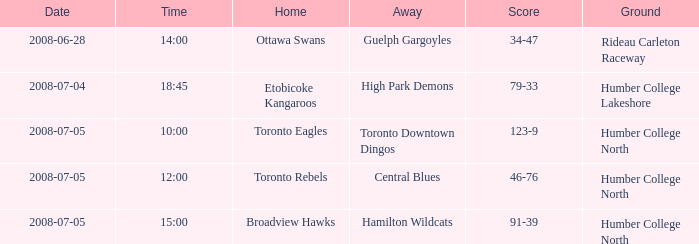Can you explain the "away with a time" concept at 14:00? Guelph Gargoyles. 